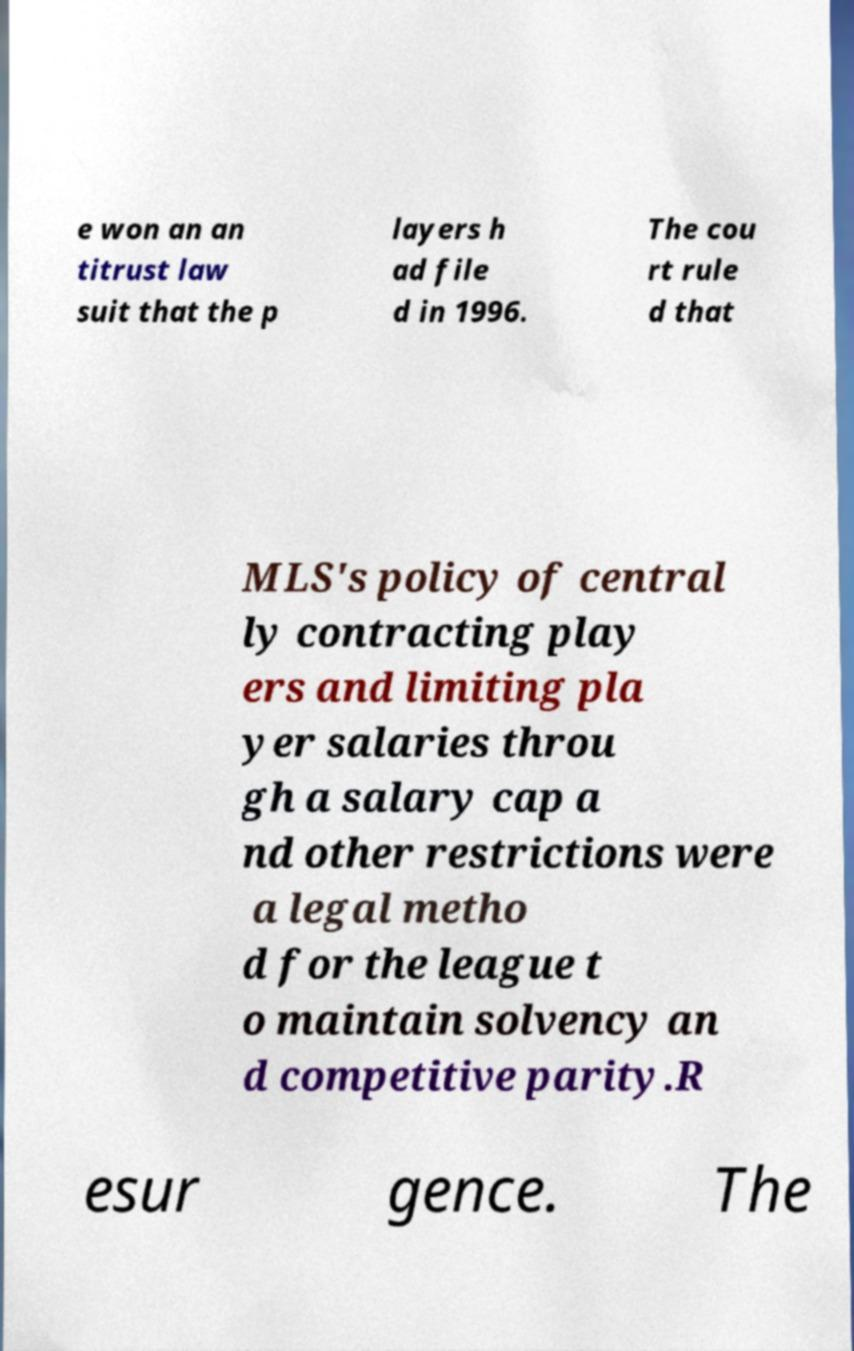What messages or text are displayed in this image? I need them in a readable, typed format. e won an an titrust law suit that the p layers h ad file d in 1996. The cou rt rule d that MLS's policy of central ly contracting play ers and limiting pla yer salaries throu gh a salary cap a nd other restrictions were a legal metho d for the league t o maintain solvency an d competitive parity.R esur gence. The 